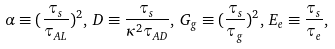Convert formula to latex. <formula><loc_0><loc_0><loc_500><loc_500>\alpha \equiv ( \frac { \tau _ { s } } { \tau _ { A L } } ) ^ { 2 } , \, D \equiv \frac { \tau _ { s } } { \kappa ^ { 2 } \tau _ { A D } } , \, G _ { g } \equiv ( \frac { \tau _ { s } } { \tau _ { g } } ) ^ { 2 } , \, E _ { e } \equiv \frac { \tau _ { s } } { \tau _ { e } } ,</formula> 